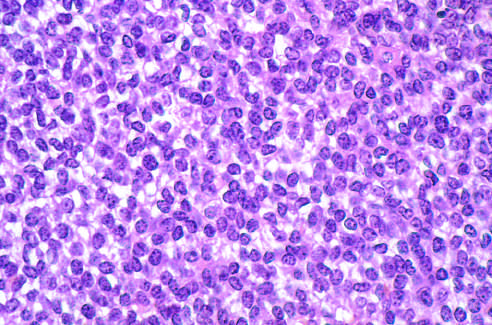s ewing sarcoma composed of sheets of small round cells with small amounts of clear cytoplasm?
Answer the question using a single word or phrase. Yes 